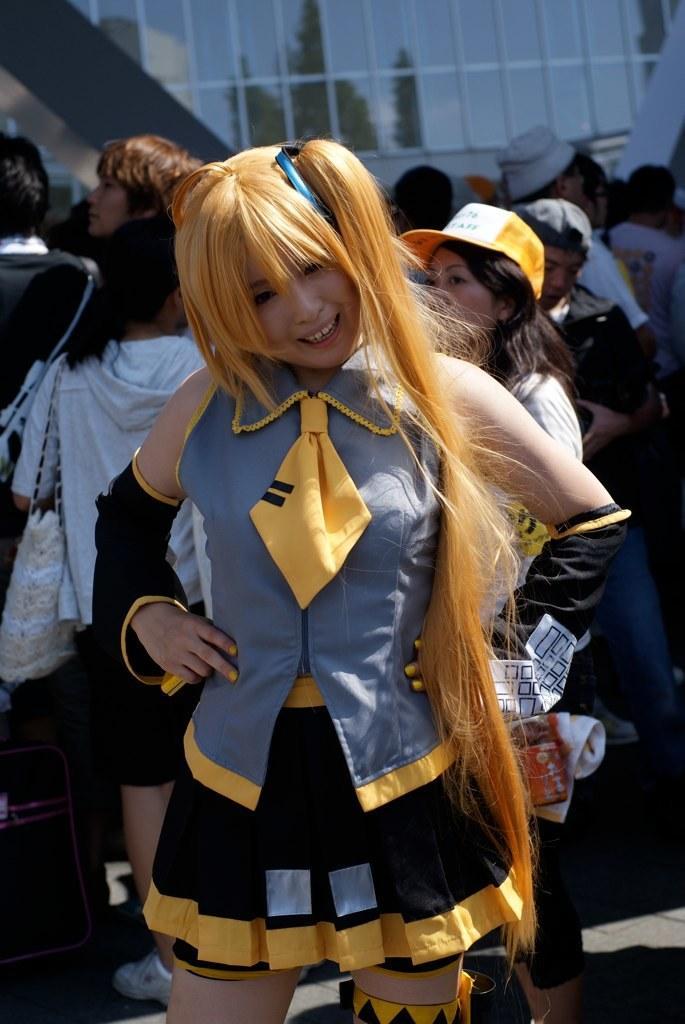Could you give a brief overview of what you see in this image? In the image in the center we can see one woman standing and she is smiling,which we can see on her face. In the background there is a glass building and few people were standing. 